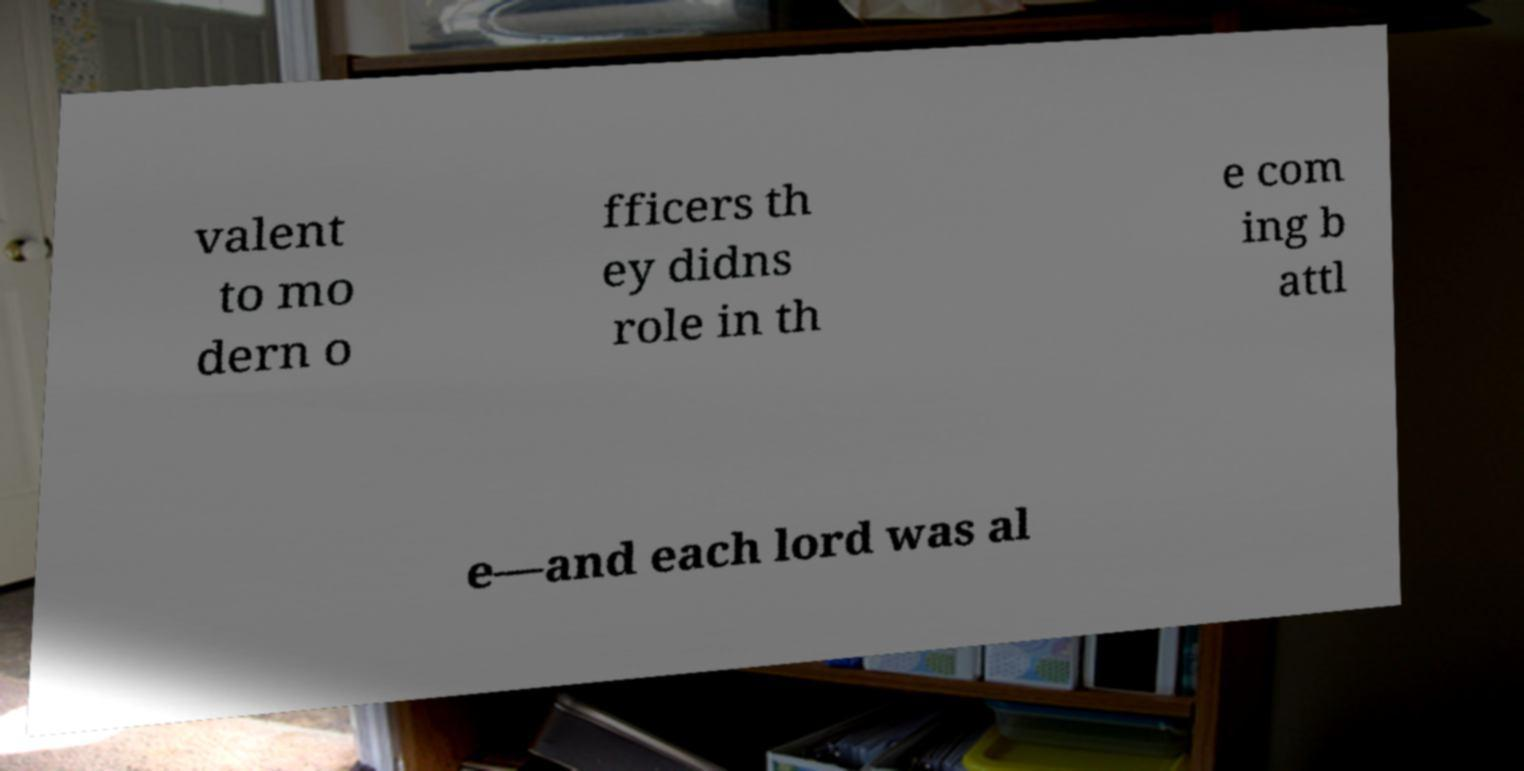I need the written content from this picture converted into text. Can you do that? valent to mo dern o fficers th ey didns role in th e com ing b attl e—and each lord was al 